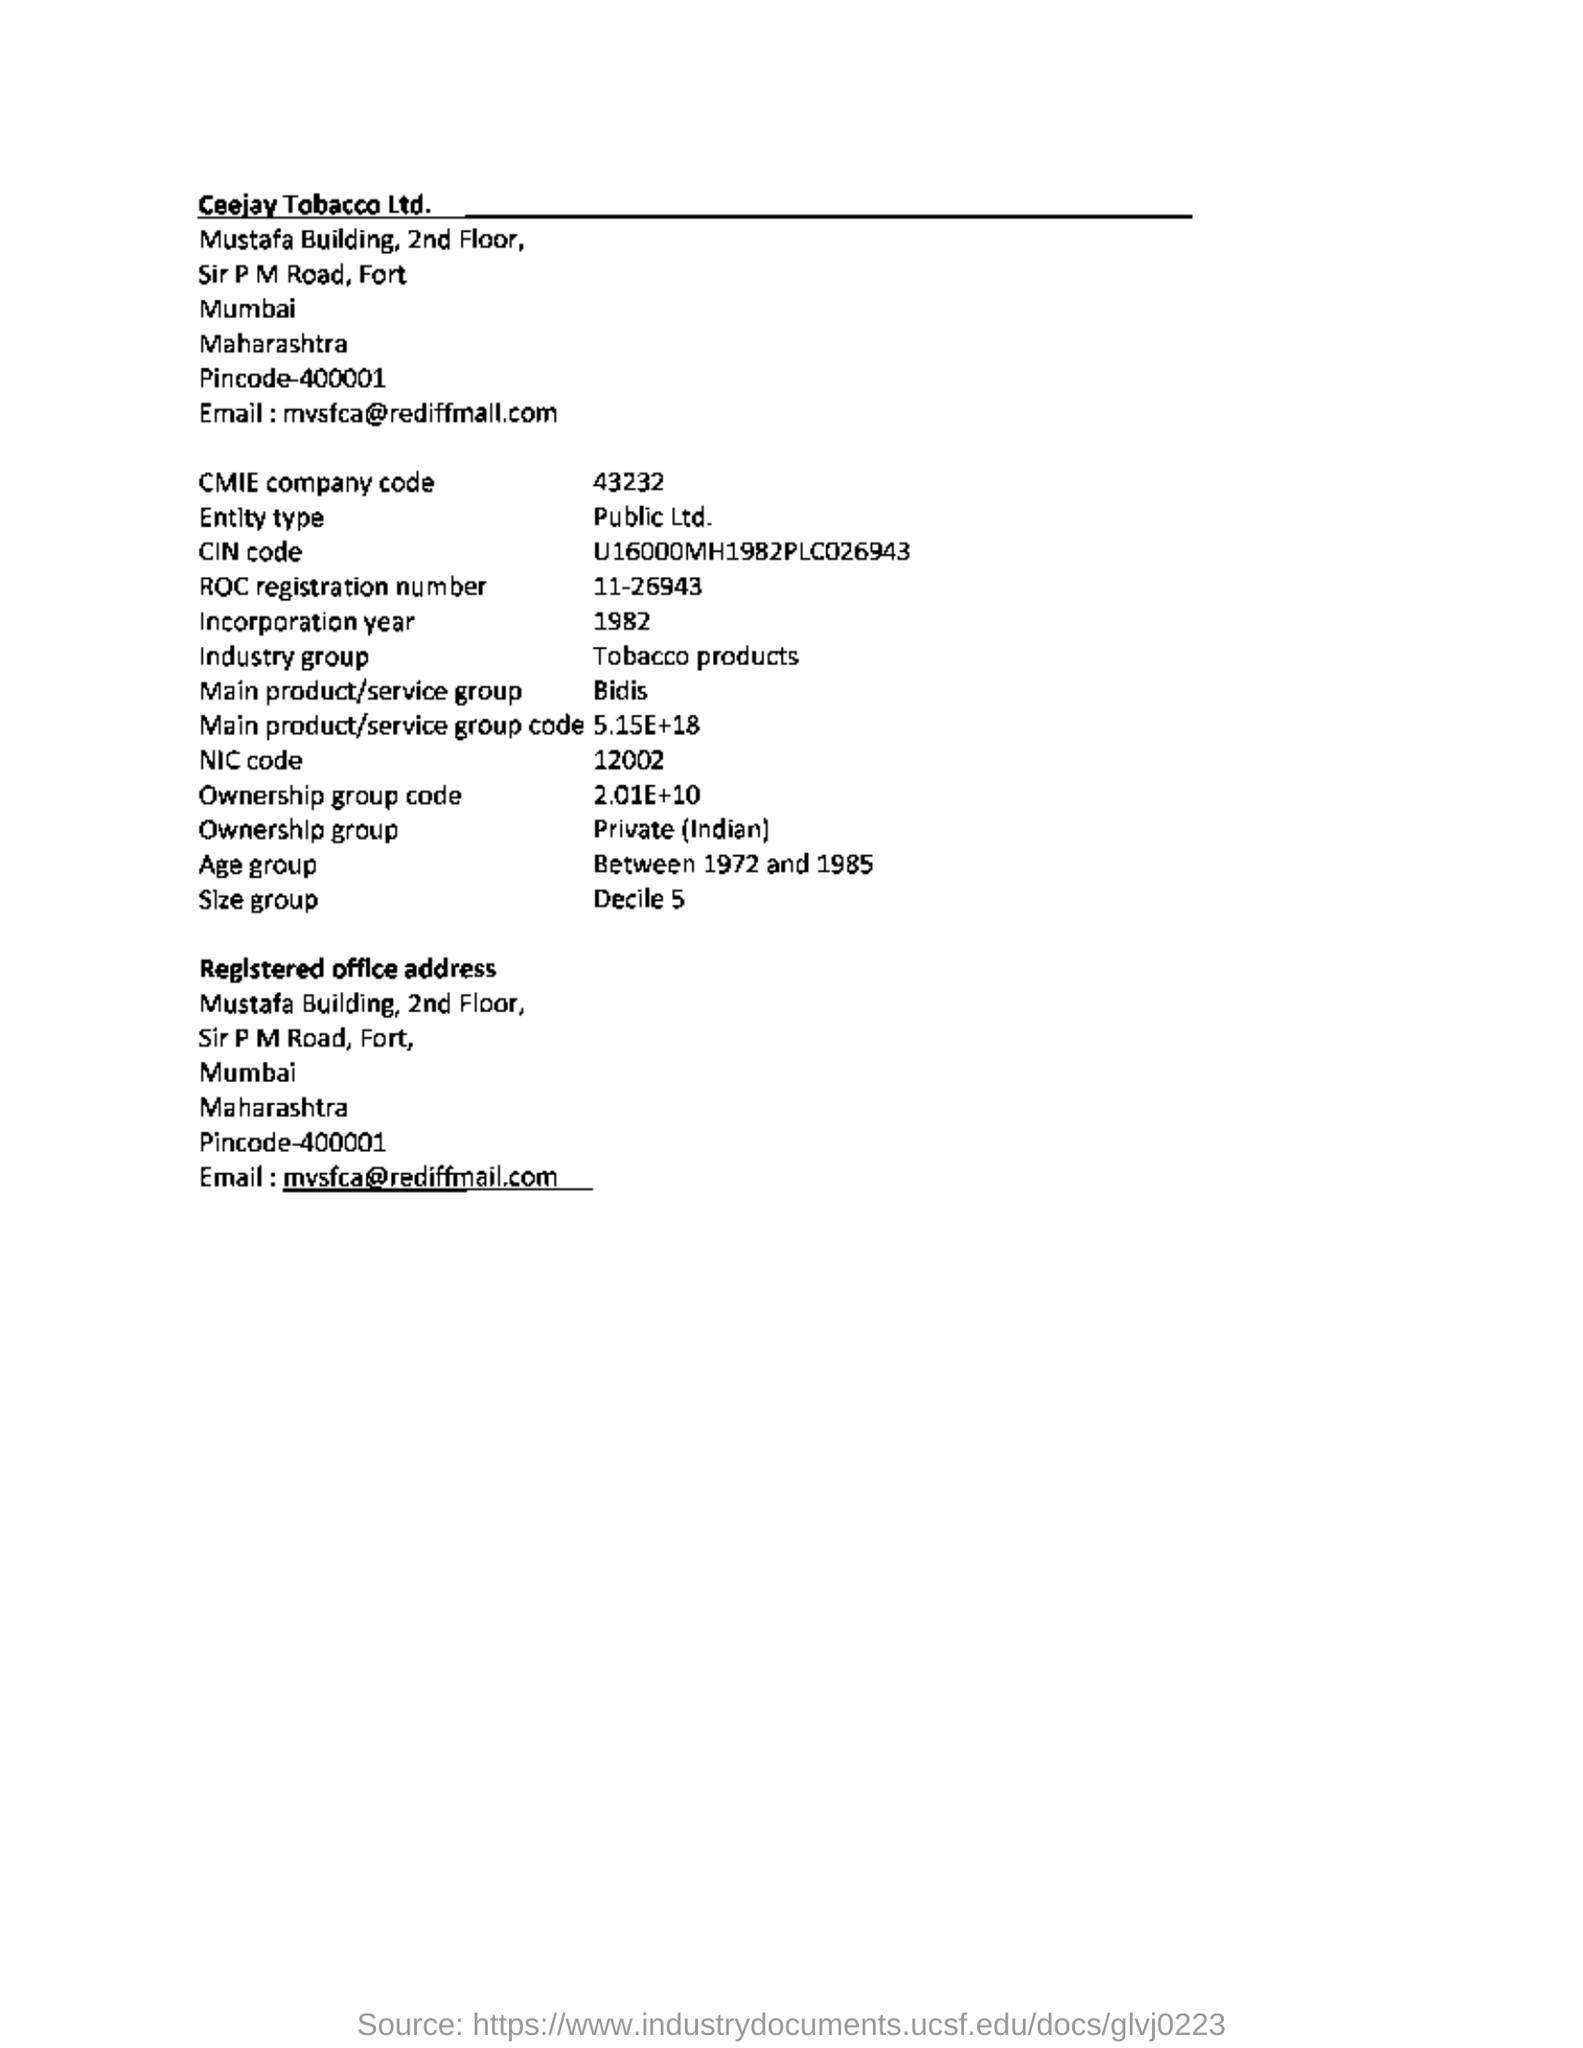Highlight a few significant elements in this photo. The document mentions a company code of 43232. The main product of the company is bidis. The age group mentioned in the document is between 1972 and 1985. 